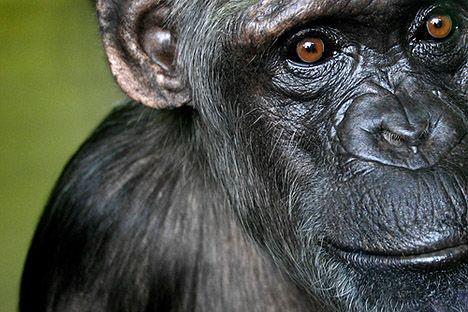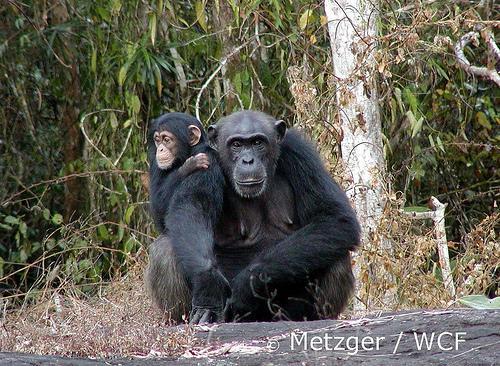The first image is the image on the left, the second image is the image on the right. Analyze the images presented: Is the assertion "There is more than one chimp in every single image." valid? Answer yes or no. No. The first image is the image on the left, the second image is the image on the right. Analyze the images presented: Is the assertion "There are at least two chimpanzees in each image." valid? Answer yes or no. No. 